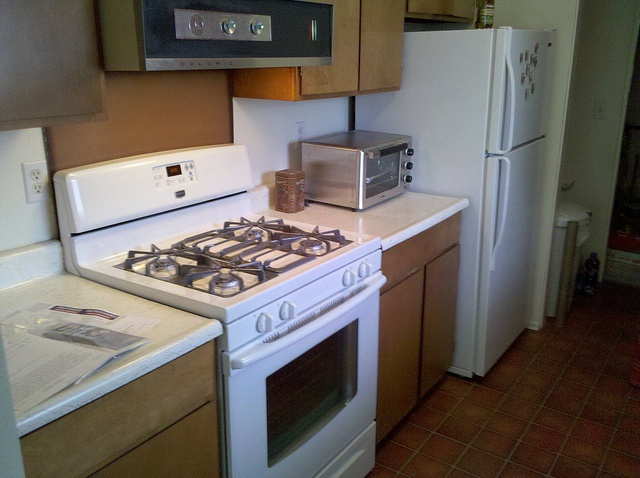Describe the objects in this image and their specific colors. I can see oven in gray, lightgray, black, and darkgray tones, refrigerator in gray and darkgray tones, oven in gray tones, and clock in gray, black, and maroon tones in this image. 